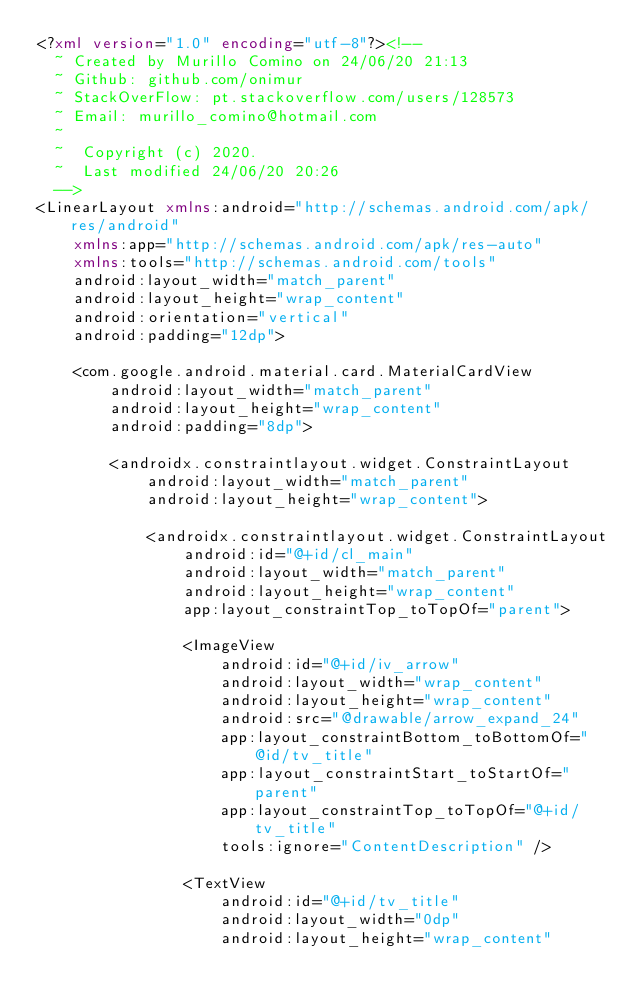Convert code to text. <code><loc_0><loc_0><loc_500><loc_500><_XML_><?xml version="1.0" encoding="utf-8"?><!--
  ~ Created by Murillo Comino on 24/06/20 21:13
  ~ Github: github.com/onimur
  ~ StackOverFlow: pt.stackoverflow.com/users/128573
  ~ Email: murillo_comino@hotmail.com
  ~
  ~  Copyright (c) 2020.
  ~  Last modified 24/06/20 20:26
  -->
<LinearLayout xmlns:android="http://schemas.android.com/apk/res/android"
    xmlns:app="http://schemas.android.com/apk/res-auto"
    xmlns:tools="http://schemas.android.com/tools"
    android:layout_width="match_parent"
    android:layout_height="wrap_content"
    android:orientation="vertical"
    android:padding="12dp">

    <com.google.android.material.card.MaterialCardView
        android:layout_width="match_parent"
        android:layout_height="wrap_content"
        android:padding="8dp">

        <androidx.constraintlayout.widget.ConstraintLayout
            android:layout_width="match_parent"
            android:layout_height="wrap_content">

            <androidx.constraintlayout.widget.ConstraintLayout
                android:id="@+id/cl_main"
                android:layout_width="match_parent"
                android:layout_height="wrap_content"
                app:layout_constraintTop_toTopOf="parent">

                <ImageView
                    android:id="@+id/iv_arrow"
                    android:layout_width="wrap_content"
                    android:layout_height="wrap_content"
                    android:src="@drawable/arrow_expand_24"
                    app:layout_constraintBottom_toBottomOf="@id/tv_title"
                    app:layout_constraintStart_toStartOf="parent"
                    app:layout_constraintTop_toTopOf="@+id/tv_title"
                    tools:ignore="ContentDescription" />

                <TextView
                    android:id="@+id/tv_title"
                    android:layout_width="0dp"
                    android:layout_height="wrap_content"</code> 